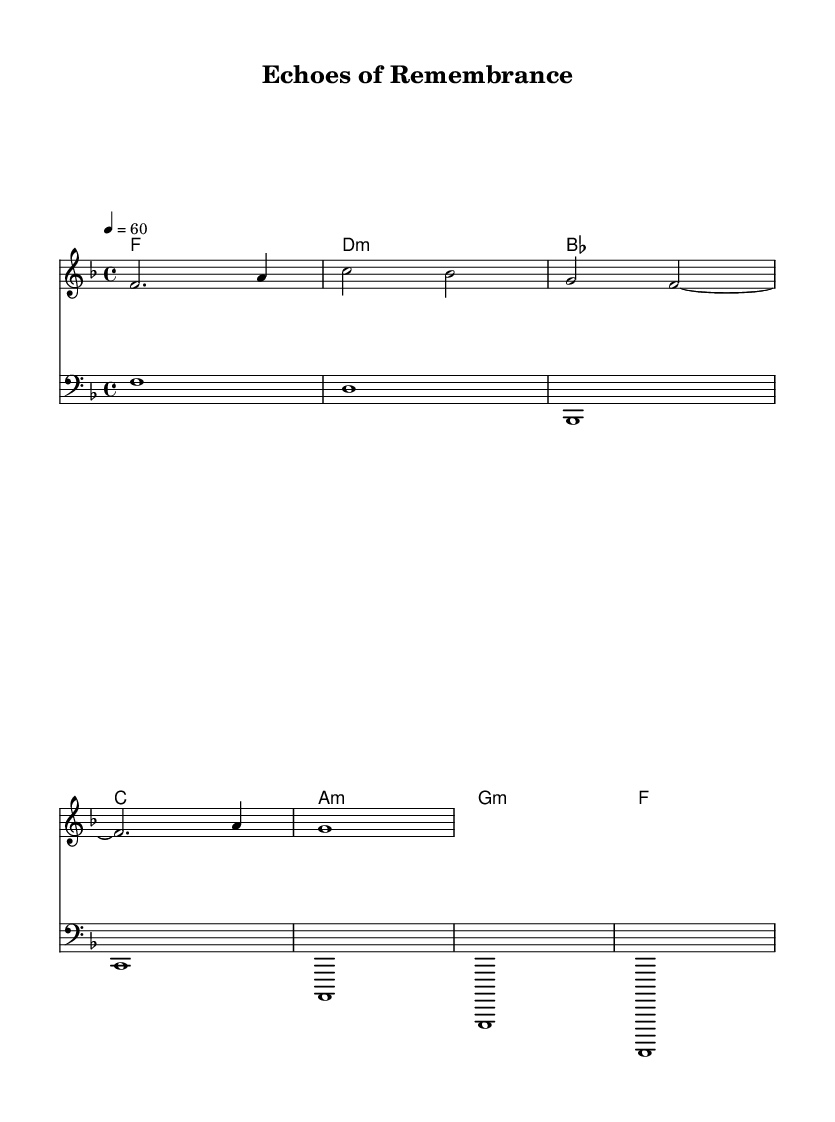What is the key signature of this music? The key signature is F major, which has one flat (B). You can tell this by looking at the key signature section at the beginning of the score where the flat is indicated.
Answer: F major What is the time signature of this music? The time signature is 4/4. This can be found at the beginning of the score where the "4/4" symbol is located, indicating four beats in each measure and a quarter note gets one beat.
Answer: 4/4 What is the tempo marking of this music? The tempo marking is 60 beats per minute. This is indicated by the text "4 = 60" in the tempo section of the score, meaning that a quarter note is played at 60 beats in one minute.
Answer: 60 How many measures are in the piece? There are eight measures. By counting each measure noted by vertical lines on the staff, we can determine the total number of measures present in the music.
Answer: 8 What is the first chord played in this music? The first chord played is F major. This is found in the chord section where "f1" is the notation for the F major chord, indicating it is the first harmony shown.
Answer: F major What is the range of the synth part? The synth part ranges from F to C. By looking at the staff, we can see that the lowest note is F (notated as f2) and the highest note reaches C (notated as c4).
Answer: F to C Which instrument plays the bass part? The bass part is played by a bass instrument. This is evident as it is notated in the bass clef, which is standard for bass instruments to indicate lower pitches.
Answer: Bass 